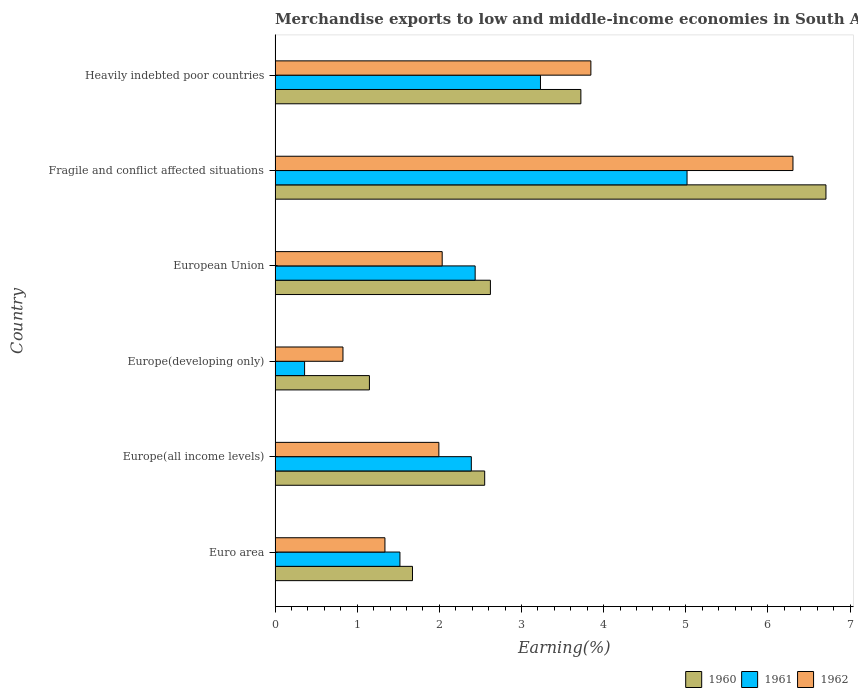How many different coloured bars are there?
Your answer should be very brief. 3. How many groups of bars are there?
Give a very brief answer. 6. Are the number of bars per tick equal to the number of legend labels?
Your answer should be compact. Yes. What is the label of the 5th group of bars from the top?
Offer a terse response. Europe(all income levels). In how many cases, is the number of bars for a given country not equal to the number of legend labels?
Make the answer very short. 0. What is the percentage of amount earned from merchandise exports in 1960 in Europe(developing only)?
Provide a succinct answer. 1.15. Across all countries, what is the maximum percentage of amount earned from merchandise exports in 1960?
Offer a very short reply. 6.71. Across all countries, what is the minimum percentage of amount earned from merchandise exports in 1960?
Provide a succinct answer. 1.15. In which country was the percentage of amount earned from merchandise exports in 1960 maximum?
Offer a very short reply. Fragile and conflict affected situations. In which country was the percentage of amount earned from merchandise exports in 1962 minimum?
Ensure brevity in your answer.  Europe(developing only). What is the total percentage of amount earned from merchandise exports in 1962 in the graph?
Provide a short and direct response. 16.34. What is the difference between the percentage of amount earned from merchandise exports in 1962 in Euro area and that in Europe(all income levels)?
Your response must be concise. -0.66. What is the difference between the percentage of amount earned from merchandise exports in 1961 in Heavily indebted poor countries and the percentage of amount earned from merchandise exports in 1960 in Fragile and conflict affected situations?
Give a very brief answer. -3.48. What is the average percentage of amount earned from merchandise exports in 1961 per country?
Offer a very short reply. 2.49. What is the difference between the percentage of amount earned from merchandise exports in 1961 and percentage of amount earned from merchandise exports in 1962 in Heavily indebted poor countries?
Give a very brief answer. -0.61. What is the ratio of the percentage of amount earned from merchandise exports in 1960 in Fragile and conflict affected situations to that in Heavily indebted poor countries?
Give a very brief answer. 1.8. Is the percentage of amount earned from merchandise exports in 1961 in Europe(developing only) less than that in European Union?
Provide a short and direct response. Yes. Is the difference between the percentage of amount earned from merchandise exports in 1961 in Euro area and Heavily indebted poor countries greater than the difference between the percentage of amount earned from merchandise exports in 1962 in Euro area and Heavily indebted poor countries?
Give a very brief answer. Yes. What is the difference between the highest and the second highest percentage of amount earned from merchandise exports in 1960?
Provide a short and direct response. 2.98. What is the difference between the highest and the lowest percentage of amount earned from merchandise exports in 1960?
Give a very brief answer. 5.56. In how many countries, is the percentage of amount earned from merchandise exports in 1960 greater than the average percentage of amount earned from merchandise exports in 1960 taken over all countries?
Give a very brief answer. 2. Is the sum of the percentage of amount earned from merchandise exports in 1960 in Europe(all income levels) and Europe(developing only) greater than the maximum percentage of amount earned from merchandise exports in 1961 across all countries?
Provide a short and direct response. No. What does the 1st bar from the bottom in Europe(developing only) represents?
Your answer should be compact. 1960. Is it the case that in every country, the sum of the percentage of amount earned from merchandise exports in 1962 and percentage of amount earned from merchandise exports in 1960 is greater than the percentage of amount earned from merchandise exports in 1961?
Provide a short and direct response. Yes. How many bars are there?
Your answer should be very brief. 18. How many countries are there in the graph?
Offer a very short reply. 6. Are the values on the major ticks of X-axis written in scientific E-notation?
Ensure brevity in your answer.  No. Does the graph contain grids?
Your response must be concise. No. Where does the legend appear in the graph?
Make the answer very short. Bottom right. How many legend labels are there?
Keep it short and to the point. 3. What is the title of the graph?
Make the answer very short. Merchandise exports to low and middle-income economies in South Asia. What is the label or title of the X-axis?
Offer a very short reply. Earning(%). What is the Earning(%) of 1960 in Euro area?
Offer a very short reply. 1.67. What is the Earning(%) of 1961 in Euro area?
Your response must be concise. 1.52. What is the Earning(%) in 1962 in Euro area?
Keep it short and to the point. 1.34. What is the Earning(%) in 1960 in Europe(all income levels)?
Your answer should be very brief. 2.55. What is the Earning(%) in 1961 in Europe(all income levels)?
Provide a succinct answer. 2.39. What is the Earning(%) in 1962 in Europe(all income levels)?
Provide a succinct answer. 1.99. What is the Earning(%) of 1960 in Europe(developing only)?
Provide a succinct answer. 1.15. What is the Earning(%) of 1961 in Europe(developing only)?
Ensure brevity in your answer.  0.36. What is the Earning(%) in 1962 in Europe(developing only)?
Give a very brief answer. 0.83. What is the Earning(%) in 1960 in European Union?
Give a very brief answer. 2.62. What is the Earning(%) of 1961 in European Union?
Provide a succinct answer. 2.44. What is the Earning(%) in 1962 in European Union?
Your answer should be very brief. 2.03. What is the Earning(%) in 1960 in Fragile and conflict affected situations?
Your answer should be very brief. 6.71. What is the Earning(%) of 1961 in Fragile and conflict affected situations?
Your answer should be compact. 5.02. What is the Earning(%) of 1962 in Fragile and conflict affected situations?
Offer a very short reply. 6.31. What is the Earning(%) of 1960 in Heavily indebted poor countries?
Make the answer very short. 3.72. What is the Earning(%) of 1961 in Heavily indebted poor countries?
Provide a short and direct response. 3.23. What is the Earning(%) in 1962 in Heavily indebted poor countries?
Make the answer very short. 3.84. Across all countries, what is the maximum Earning(%) in 1960?
Ensure brevity in your answer.  6.71. Across all countries, what is the maximum Earning(%) in 1961?
Offer a very short reply. 5.02. Across all countries, what is the maximum Earning(%) of 1962?
Offer a terse response. 6.31. Across all countries, what is the minimum Earning(%) of 1960?
Provide a succinct answer. 1.15. Across all countries, what is the minimum Earning(%) of 1961?
Offer a very short reply. 0.36. Across all countries, what is the minimum Earning(%) in 1962?
Provide a succinct answer. 0.83. What is the total Earning(%) in 1960 in the graph?
Your answer should be compact. 18.43. What is the total Earning(%) in 1961 in the graph?
Offer a terse response. 14.95. What is the total Earning(%) of 1962 in the graph?
Your answer should be compact. 16.34. What is the difference between the Earning(%) of 1960 in Euro area and that in Europe(all income levels)?
Provide a short and direct response. -0.88. What is the difference between the Earning(%) of 1961 in Euro area and that in Europe(all income levels)?
Keep it short and to the point. -0.87. What is the difference between the Earning(%) of 1962 in Euro area and that in Europe(all income levels)?
Your answer should be compact. -0.66. What is the difference between the Earning(%) in 1960 in Euro area and that in Europe(developing only)?
Your answer should be very brief. 0.52. What is the difference between the Earning(%) in 1961 in Euro area and that in Europe(developing only)?
Your answer should be very brief. 1.16. What is the difference between the Earning(%) in 1962 in Euro area and that in Europe(developing only)?
Give a very brief answer. 0.51. What is the difference between the Earning(%) in 1960 in Euro area and that in European Union?
Your answer should be compact. -0.95. What is the difference between the Earning(%) of 1961 in Euro area and that in European Union?
Ensure brevity in your answer.  -0.92. What is the difference between the Earning(%) of 1962 in Euro area and that in European Union?
Offer a terse response. -0.7. What is the difference between the Earning(%) in 1960 in Euro area and that in Fragile and conflict affected situations?
Make the answer very short. -5.03. What is the difference between the Earning(%) of 1961 in Euro area and that in Fragile and conflict affected situations?
Your answer should be very brief. -3.5. What is the difference between the Earning(%) in 1962 in Euro area and that in Fragile and conflict affected situations?
Your response must be concise. -4.97. What is the difference between the Earning(%) in 1960 in Euro area and that in Heavily indebted poor countries?
Offer a very short reply. -2.05. What is the difference between the Earning(%) of 1961 in Euro area and that in Heavily indebted poor countries?
Keep it short and to the point. -1.71. What is the difference between the Earning(%) of 1962 in Euro area and that in Heavily indebted poor countries?
Offer a very short reply. -2.51. What is the difference between the Earning(%) of 1960 in Europe(all income levels) and that in Europe(developing only)?
Offer a very short reply. 1.4. What is the difference between the Earning(%) in 1961 in Europe(all income levels) and that in Europe(developing only)?
Make the answer very short. 2.03. What is the difference between the Earning(%) in 1962 in Europe(all income levels) and that in Europe(developing only)?
Your response must be concise. 1.17. What is the difference between the Earning(%) in 1960 in Europe(all income levels) and that in European Union?
Offer a very short reply. -0.07. What is the difference between the Earning(%) in 1961 in Europe(all income levels) and that in European Union?
Offer a terse response. -0.05. What is the difference between the Earning(%) in 1962 in Europe(all income levels) and that in European Union?
Your answer should be compact. -0.04. What is the difference between the Earning(%) in 1960 in Europe(all income levels) and that in Fragile and conflict affected situations?
Offer a very short reply. -4.15. What is the difference between the Earning(%) of 1961 in Europe(all income levels) and that in Fragile and conflict affected situations?
Offer a very short reply. -2.63. What is the difference between the Earning(%) of 1962 in Europe(all income levels) and that in Fragile and conflict affected situations?
Provide a short and direct response. -4.31. What is the difference between the Earning(%) of 1960 in Europe(all income levels) and that in Heavily indebted poor countries?
Make the answer very short. -1.17. What is the difference between the Earning(%) of 1961 in Europe(all income levels) and that in Heavily indebted poor countries?
Your response must be concise. -0.84. What is the difference between the Earning(%) of 1962 in Europe(all income levels) and that in Heavily indebted poor countries?
Provide a succinct answer. -1.85. What is the difference between the Earning(%) of 1960 in Europe(developing only) and that in European Union?
Provide a succinct answer. -1.47. What is the difference between the Earning(%) in 1961 in Europe(developing only) and that in European Union?
Your response must be concise. -2.08. What is the difference between the Earning(%) of 1962 in Europe(developing only) and that in European Union?
Offer a very short reply. -1.21. What is the difference between the Earning(%) in 1960 in Europe(developing only) and that in Fragile and conflict affected situations?
Ensure brevity in your answer.  -5.56. What is the difference between the Earning(%) of 1961 in Europe(developing only) and that in Fragile and conflict affected situations?
Keep it short and to the point. -4.66. What is the difference between the Earning(%) of 1962 in Europe(developing only) and that in Fragile and conflict affected situations?
Your answer should be compact. -5.48. What is the difference between the Earning(%) of 1960 in Europe(developing only) and that in Heavily indebted poor countries?
Provide a short and direct response. -2.57. What is the difference between the Earning(%) of 1961 in Europe(developing only) and that in Heavily indebted poor countries?
Offer a very short reply. -2.87. What is the difference between the Earning(%) of 1962 in Europe(developing only) and that in Heavily indebted poor countries?
Your answer should be very brief. -3.02. What is the difference between the Earning(%) in 1960 in European Union and that in Fragile and conflict affected situations?
Make the answer very short. -4.09. What is the difference between the Earning(%) of 1961 in European Union and that in Fragile and conflict affected situations?
Make the answer very short. -2.58. What is the difference between the Earning(%) in 1962 in European Union and that in Fragile and conflict affected situations?
Make the answer very short. -4.27. What is the difference between the Earning(%) of 1960 in European Union and that in Heavily indebted poor countries?
Your answer should be compact. -1.1. What is the difference between the Earning(%) in 1961 in European Union and that in Heavily indebted poor countries?
Ensure brevity in your answer.  -0.8. What is the difference between the Earning(%) in 1962 in European Union and that in Heavily indebted poor countries?
Provide a succinct answer. -1.81. What is the difference between the Earning(%) of 1960 in Fragile and conflict affected situations and that in Heavily indebted poor countries?
Offer a terse response. 2.98. What is the difference between the Earning(%) of 1961 in Fragile and conflict affected situations and that in Heavily indebted poor countries?
Keep it short and to the point. 1.78. What is the difference between the Earning(%) in 1962 in Fragile and conflict affected situations and that in Heavily indebted poor countries?
Your response must be concise. 2.46. What is the difference between the Earning(%) in 1960 in Euro area and the Earning(%) in 1961 in Europe(all income levels)?
Make the answer very short. -0.72. What is the difference between the Earning(%) in 1960 in Euro area and the Earning(%) in 1962 in Europe(all income levels)?
Keep it short and to the point. -0.32. What is the difference between the Earning(%) of 1961 in Euro area and the Earning(%) of 1962 in Europe(all income levels)?
Offer a terse response. -0.47. What is the difference between the Earning(%) of 1960 in Euro area and the Earning(%) of 1961 in Europe(developing only)?
Provide a succinct answer. 1.31. What is the difference between the Earning(%) in 1960 in Euro area and the Earning(%) in 1962 in Europe(developing only)?
Keep it short and to the point. 0.85. What is the difference between the Earning(%) in 1961 in Euro area and the Earning(%) in 1962 in Europe(developing only)?
Keep it short and to the point. 0.69. What is the difference between the Earning(%) of 1960 in Euro area and the Earning(%) of 1961 in European Union?
Offer a terse response. -0.76. What is the difference between the Earning(%) in 1960 in Euro area and the Earning(%) in 1962 in European Union?
Keep it short and to the point. -0.36. What is the difference between the Earning(%) in 1961 in Euro area and the Earning(%) in 1962 in European Union?
Keep it short and to the point. -0.51. What is the difference between the Earning(%) in 1960 in Euro area and the Earning(%) in 1961 in Fragile and conflict affected situations?
Offer a very short reply. -3.34. What is the difference between the Earning(%) of 1960 in Euro area and the Earning(%) of 1962 in Fragile and conflict affected situations?
Ensure brevity in your answer.  -4.63. What is the difference between the Earning(%) in 1961 in Euro area and the Earning(%) in 1962 in Fragile and conflict affected situations?
Give a very brief answer. -4.79. What is the difference between the Earning(%) in 1960 in Euro area and the Earning(%) in 1961 in Heavily indebted poor countries?
Provide a short and direct response. -1.56. What is the difference between the Earning(%) in 1960 in Euro area and the Earning(%) in 1962 in Heavily indebted poor countries?
Your answer should be compact. -2.17. What is the difference between the Earning(%) in 1961 in Euro area and the Earning(%) in 1962 in Heavily indebted poor countries?
Your answer should be very brief. -2.32. What is the difference between the Earning(%) in 1960 in Europe(all income levels) and the Earning(%) in 1961 in Europe(developing only)?
Keep it short and to the point. 2.19. What is the difference between the Earning(%) in 1960 in Europe(all income levels) and the Earning(%) in 1962 in Europe(developing only)?
Your answer should be compact. 1.73. What is the difference between the Earning(%) of 1961 in Europe(all income levels) and the Earning(%) of 1962 in Europe(developing only)?
Offer a very short reply. 1.56. What is the difference between the Earning(%) of 1960 in Europe(all income levels) and the Earning(%) of 1961 in European Union?
Offer a very short reply. 0.12. What is the difference between the Earning(%) of 1960 in Europe(all income levels) and the Earning(%) of 1962 in European Union?
Your response must be concise. 0.52. What is the difference between the Earning(%) in 1961 in Europe(all income levels) and the Earning(%) in 1962 in European Union?
Make the answer very short. 0.35. What is the difference between the Earning(%) in 1960 in Europe(all income levels) and the Earning(%) in 1961 in Fragile and conflict affected situations?
Your response must be concise. -2.46. What is the difference between the Earning(%) in 1960 in Europe(all income levels) and the Earning(%) in 1962 in Fragile and conflict affected situations?
Make the answer very short. -3.75. What is the difference between the Earning(%) in 1961 in Europe(all income levels) and the Earning(%) in 1962 in Fragile and conflict affected situations?
Make the answer very short. -3.92. What is the difference between the Earning(%) in 1960 in Europe(all income levels) and the Earning(%) in 1961 in Heavily indebted poor countries?
Your answer should be very brief. -0.68. What is the difference between the Earning(%) in 1960 in Europe(all income levels) and the Earning(%) in 1962 in Heavily indebted poor countries?
Your response must be concise. -1.29. What is the difference between the Earning(%) in 1961 in Europe(all income levels) and the Earning(%) in 1962 in Heavily indebted poor countries?
Provide a succinct answer. -1.46. What is the difference between the Earning(%) of 1960 in Europe(developing only) and the Earning(%) of 1961 in European Union?
Your answer should be compact. -1.29. What is the difference between the Earning(%) in 1960 in Europe(developing only) and the Earning(%) in 1962 in European Union?
Your answer should be compact. -0.89. What is the difference between the Earning(%) of 1961 in Europe(developing only) and the Earning(%) of 1962 in European Union?
Make the answer very short. -1.68. What is the difference between the Earning(%) of 1960 in Europe(developing only) and the Earning(%) of 1961 in Fragile and conflict affected situations?
Provide a succinct answer. -3.87. What is the difference between the Earning(%) in 1960 in Europe(developing only) and the Earning(%) in 1962 in Fragile and conflict affected situations?
Your answer should be compact. -5.16. What is the difference between the Earning(%) of 1961 in Europe(developing only) and the Earning(%) of 1962 in Fragile and conflict affected situations?
Give a very brief answer. -5.95. What is the difference between the Earning(%) of 1960 in Europe(developing only) and the Earning(%) of 1961 in Heavily indebted poor countries?
Keep it short and to the point. -2.08. What is the difference between the Earning(%) of 1960 in Europe(developing only) and the Earning(%) of 1962 in Heavily indebted poor countries?
Give a very brief answer. -2.7. What is the difference between the Earning(%) of 1961 in Europe(developing only) and the Earning(%) of 1962 in Heavily indebted poor countries?
Your response must be concise. -3.49. What is the difference between the Earning(%) in 1960 in European Union and the Earning(%) in 1961 in Fragile and conflict affected situations?
Your answer should be very brief. -2.39. What is the difference between the Earning(%) in 1960 in European Union and the Earning(%) in 1962 in Fragile and conflict affected situations?
Your answer should be compact. -3.68. What is the difference between the Earning(%) of 1961 in European Union and the Earning(%) of 1962 in Fragile and conflict affected situations?
Your answer should be very brief. -3.87. What is the difference between the Earning(%) in 1960 in European Union and the Earning(%) in 1961 in Heavily indebted poor countries?
Provide a short and direct response. -0.61. What is the difference between the Earning(%) of 1960 in European Union and the Earning(%) of 1962 in Heavily indebted poor countries?
Keep it short and to the point. -1.22. What is the difference between the Earning(%) in 1961 in European Union and the Earning(%) in 1962 in Heavily indebted poor countries?
Offer a very short reply. -1.41. What is the difference between the Earning(%) of 1960 in Fragile and conflict affected situations and the Earning(%) of 1961 in Heavily indebted poor countries?
Keep it short and to the point. 3.48. What is the difference between the Earning(%) in 1960 in Fragile and conflict affected situations and the Earning(%) in 1962 in Heavily indebted poor countries?
Provide a short and direct response. 2.86. What is the difference between the Earning(%) of 1961 in Fragile and conflict affected situations and the Earning(%) of 1962 in Heavily indebted poor countries?
Ensure brevity in your answer.  1.17. What is the average Earning(%) in 1960 per country?
Provide a short and direct response. 3.07. What is the average Earning(%) of 1961 per country?
Make the answer very short. 2.49. What is the average Earning(%) of 1962 per country?
Provide a succinct answer. 2.72. What is the difference between the Earning(%) in 1960 and Earning(%) in 1961 in Euro area?
Make the answer very short. 0.15. What is the difference between the Earning(%) of 1960 and Earning(%) of 1962 in Euro area?
Give a very brief answer. 0.34. What is the difference between the Earning(%) in 1961 and Earning(%) in 1962 in Euro area?
Keep it short and to the point. 0.18. What is the difference between the Earning(%) of 1960 and Earning(%) of 1961 in Europe(all income levels)?
Your answer should be compact. 0.16. What is the difference between the Earning(%) in 1960 and Earning(%) in 1962 in Europe(all income levels)?
Make the answer very short. 0.56. What is the difference between the Earning(%) of 1961 and Earning(%) of 1962 in Europe(all income levels)?
Ensure brevity in your answer.  0.4. What is the difference between the Earning(%) in 1960 and Earning(%) in 1961 in Europe(developing only)?
Give a very brief answer. 0.79. What is the difference between the Earning(%) in 1960 and Earning(%) in 1962 in Europe(developing only)?
Your response must be concise. 0.32. What is the difference between the Earning(%) in 1961 and Earning(%) in 1962 in Europe(developing only)?
Keep it short and to the point. -0.47. What is the difference between the Earning(%) of 1960 and Earning(%) of 1961 in European Union?
Your response must be concise. 0.19. What is the difference between the Earning(%) in 1960 and Earning(%) in 1962 in European Union?
Provide a short and direct response. 0.59. What is the difference between the Earning(%) of 1961 and Earning(%) of 1962 in European Union?
Make the answer very short. 0.4. What is the difference between the Earning(%) in 1960 and Earning(%) in 1961 in Fragile and conflict affected situations?
Ensure brevity in your answer.  1.69. What is the difference between the Earning(%) in 1960 and Earning(%) in 1962 in Fragile and conflict affected situations?
Your answer should be very brief. 0.4. What is the difference between the Earning(%) of 1961 and Earning(%) of 1962 in Fragile and conflict affected situations?
Ensure brevity in your answer.  -1.29. What is the difference between the Earning(%) in 1960 and Earning(%) in 1961 in Heavily indebted poor countries?
Your answer should be very brief. 0.49. What is the difference between the Earning(%) of 1960 and Earning(%) of 1962 in Heavily indebted poor countries?
Provide a succinct answer. -0.12. What is the difference between the Earning(%) in 1961 and Earning(%) in 1962 in Heavily indebted poor countries?
Your answer should be very brief. -0.61. What is the ratio of the Earning(%) in 1960 in Euro area to that in Europe(all income levels)?
Ensure brevity in your answer.  0.66. What is the ratio of the Earning(%) in 1961 in Euro area to that in Europe(all income levels)?
Ensure brevity in your answer.  0.64. What is the ratio of the Earning(%) in 1962 in Euro area to that in Europe(all income levels)?
Ensure brevity in your answer.  0.67. What is the ratio of the Earning(%) in 1960 in Euro area to that in Europe(developing only)?
Give a very brief answer. 1.46. What is the ratio of the Earning(%) in 1961 in Euro area to that in Europe(developing only)?
Provide a succinct answer. 4.23. What is the ratio of the Earning(%) of 1962 in Euro area to that in Europe(developing only)?
Offer a terse response. 1.62. What is the ratio of the Earning(%) in 1960 in Euro area to that in European Union?
Provide a succinct answer. 0.64. What is the ratio of the Earning(%) of 1961 in Euro area to that in European Union?
Provide a succinct answer. 0.62. What is the ratio of the Earning(%) of 1962 in Euro area to that in European Union?
Your response must be concise. 0.66. What is the ratio of the Earning(%) in 1960 in Euro area to that in Fragile and conflict affected situations?
Offer a terse response. 0.25. What is the ratio of the Earning(%) in 1961 in Euro area to that in Fragile and conflict affected situations?
Give a very brief answer. 0.3. What is the ratio of the Earning(%) in 1962 in Euro area to that in Fragile and conflict affected situations?
Offer a terse response. 0.21. What is the ratio of the Earning(%) of 1960 in Euro area to that in Heavily indebted poor countries?
Offer a terse response. 0.45. What is the ratio of the Earning(%) in 1961 in Euro area to that in Heavily indebted poor countries?
Provide a succinct answer. 0.47. What is the ratio of the Earning(%) in 1962 in Euro area to that in Heavily indebted poor countries?
Give a very brief answer. 0.35. What is the ratio of the Earning(%) of 1960 in Europe(all income levels) to that in Europe(developing only)?
Your answer should be very brief. 2.22. What is the ratio of the Earning(%) of 1961 in Europe(all income levels) to that in Europe(developing only)?
Give a very brief answer. 6.65. What is the ratio of the Earning(%) of 1962 in Europe(all income levels) to that in Europe(developing only)?
Give a very brief answer. 2.41. What is the ratio of the Earning(%) of 1960 in Europe(all income levels) to that in European Union?
Make the answer very short. 0.97. What is the ratio of the Earning(%) in 1961 in Europe(all income levels) to that in European Union?
Provide a succinct answer. 0.98. What is the ratio of the Earning(%) of 1962 in Europe(all income levels) to that in European Union?
Keep it short and to the point. 0.98. What is the ratio of the Earning(%) of 1960 in Europe(all income levels) to that in Fragile and conflict affected situations?
Provide a short and direct response. 0.38. What is the ratio of the Earning(%) of 1961 in Europe(all income levels) to that in Fragile and conflict affected situations?
Your answer should be compact. 0.48. What is the ratio of the Earning(%) of 1962 in Europe(all income levels) to that in Fragile and conflict affected situations?
Your answer should be very brief. 0.32. What is the ratio of the Earning(%) in 1960 in Europe(all income levels) to that in Heavily indebted poor countries?
Keep it short and to the point. 0.69. What is the ratio of the Earning(%) in 1961 in Europe(all income levels) to that in Heavily indebted poor countries?
Provide a succinct answer. 0.74. What is the ratio of the Earning(%) of 1962 in Europe(all income levels) to that in Heavily indebted poor countries?
Provide a short and direct response. 0.52. What is the ratio of the Earning(%) of 1960 in Europe(developing only) to that in European Union?
Provide a short and direct response. 0.44. What is the ratio of the Earning(%) in 1961 in Europe(developing only) to that in European Union?
Your answer should be compact. 0.15. What is the ratio of the Earning(%) of 1962 in Europe(developing only) to that in European Union?
Your answer should be compact. 0.41. What is the ratio of the Earning(%) in 1960 in Europe(developing only) to that in Fragile and conflict affected situations?
Your response must be concise. 0.17. What is the ratio of the Earning(%) of 1961 in Europe(developing only) to that in Fragile and conflict affected situations?
Your answer should be compact. 0.07. What is the ratio of the Earning(%) in 1962 in Europe(developing only) to that in Fragile and conflict affected situations?
Give a very brief answer. 0.13. What is the ratio of the Earning(%) of 1960 in Europe(developing only) to that in Heavily indebted poor countries?
Give a very brief answer. 0.31. What is the ratio of the Earning(%) in 1961 in Europe(developing only) to that in Heavily indebted poor countries?
Give a very brief answer. 0.11. What is the ratio of the Earning(%) in 1962 in Europe(developing only) to that in Heavily indebted poor countries?
Make the answer very short. 0.21. What is the ratio of the Earning(%) in 1960 in European Union to that in Fragile and conflict affected situations?
Offer a very short reply. 0.39. What is the ratio of the Earning(%) of 1961 in European Union to that in Fragile and conflict affected situations?
Make the answer very short. 0.49. What is the ratio of the Earning(%) in 1962 in European Union to that in Fragile and conflict affected situations?
Provide a succinct answer. 0.32. What is the ratio of the Earning(%) in 1960 in European Union to that in Heavily indebted poor countries?
Make the answer very short. 0.7. What is the ratio of the Earning(%) of 1961 in European Union to that in Heavily indebted poor countries?
Make the answer very short. 0.75. What is the ratio of the Earning(%) in 1962 in European Union to that in Heavily indebted poor countries?
Your response must be concise. 0.53. What is the ratio of the Earning(%) of 1960 in Fragile and conflict affected situations to that in Heavily indebted poor countries?
Give a very brief answer. 1.8. What is the ratio of the Earning(%) in 1961 in Fragile and conflict affected situations to that in Heavily indebted poor countries?
Your answer should be compact. 1.55. What is the ratio of the Earning(%) of 1962 in Fragile and conflict affected situations to that in Heavily indebted poor countries?
Keep it short and to the point. 1.64. What is the difference between the highest and the second highest Earning(%) of 1960?
Give a very brief answer. 2.98. What is the difference between the highest and the second highest Earning(%) of 1961?
Ensure brevity in your answer.  1.78. What is the difference between the highest and the second highest Earning(%) in 1962?
Offer a terse response. 2.46. What is the difference between the highest and the lowest Earning(%) of 1960?
Ensure brevity in your answer.  5.56. What is the difference between the highest and the lowest Earning(%) in 1961?
Your answer should be very brief. 4.66. What is the difference between the highest and the lowest Earning(%) in 1962?
Your response must be concise. 5.48. 